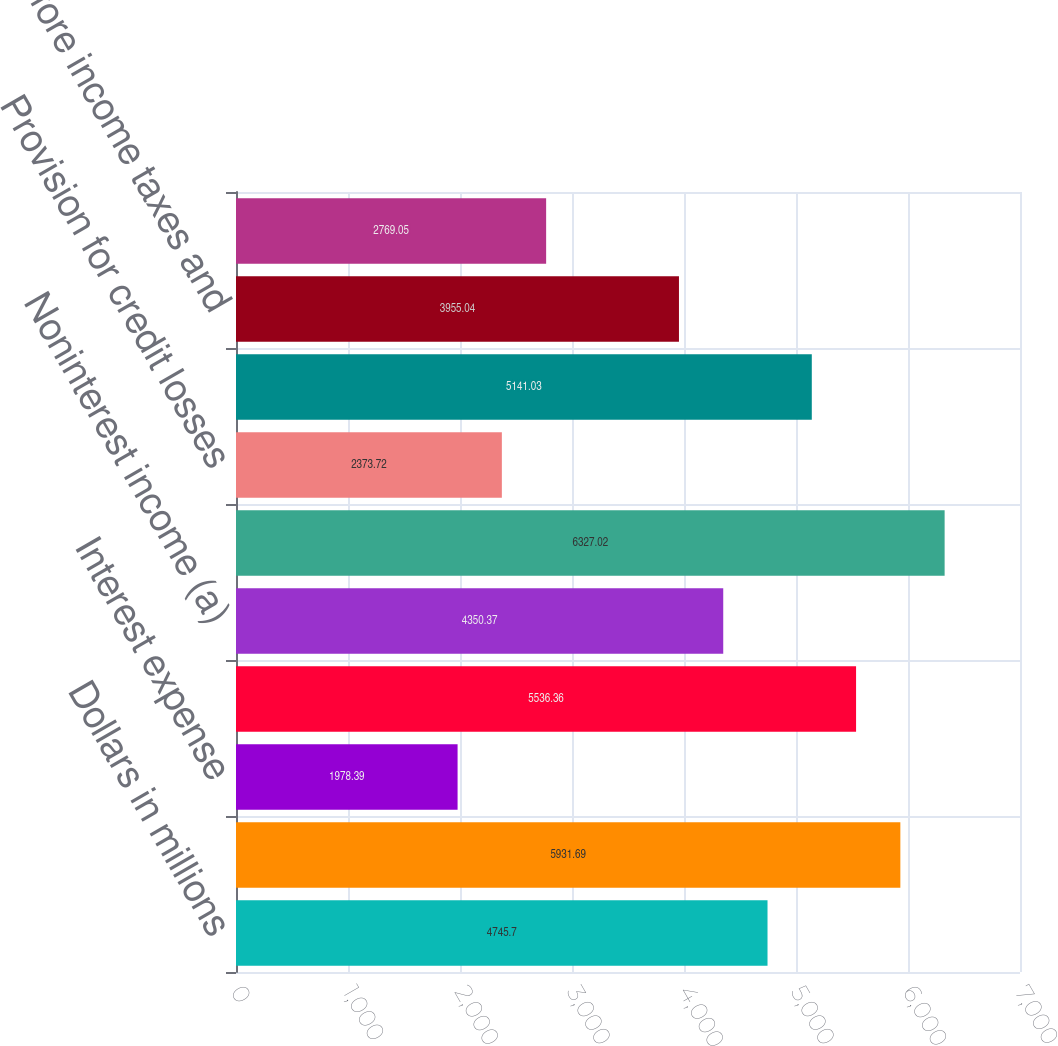Convert chart. <chart><loc_0><loc_0><loc_500><loc_500><bar_chart><fcel>Dollars in millions<fcel>Interest income<fcel>Interest expense<fcel>Net interest income<fcel>Noninterest income (a)<fcel>Total revenue<fcel>Provision for credit losses<fcel>Noninterest expense (b)<fcel>Income before income taxes and<fcel>Income taxes (b)<nl><fcel>4745.7<fcel>5931.69<fcel>1978.39<fcel>5536.36<fcel>4350.37<fcel>6327.02<fcel>2373.72<fcel>5141.03<fcel>3955.04<fcel>2769.05<nl></chart> 